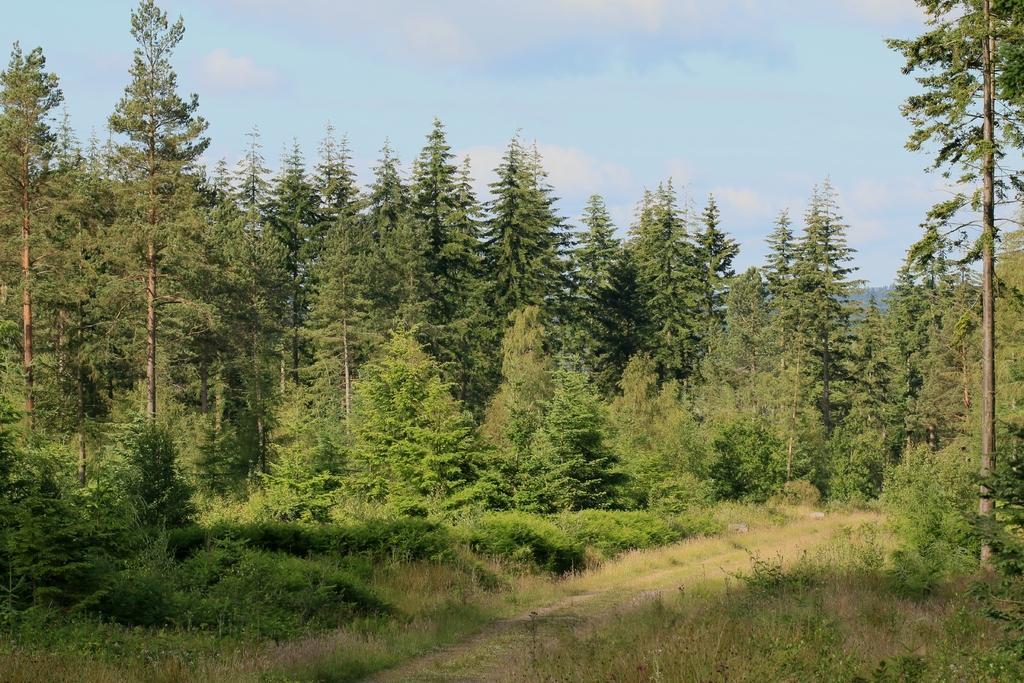Could you give a brief overview of what you see in this image? In this image I can see a forest are and I can see trees and grass ,at the top I can see the sky. 